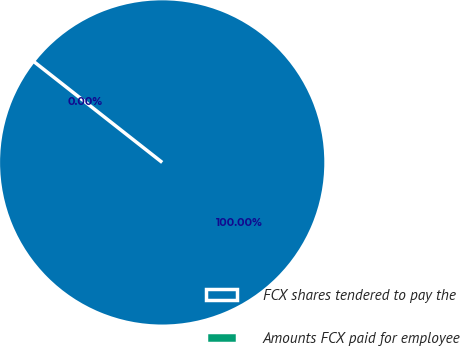<chart> <loc_0><loc_0><loc_500><loc_500><pie_chart><fcel>FCX shares tendered to pay the<fcel>Amounts FCX paid for employee<nl><fcel>100.0%<fcel>0.0%<nl></chart> 